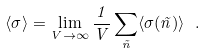Convert formula to latex. <formula><loc_0><loc_0><loc_500><loc_500>\langle \sigma \rangle = \lim _ { V \to \infty } \frac { 1 } { V } \sum _ { \vec { n } } \langle \sigma ( \vec { n } ) \rangle \ .</formula> 